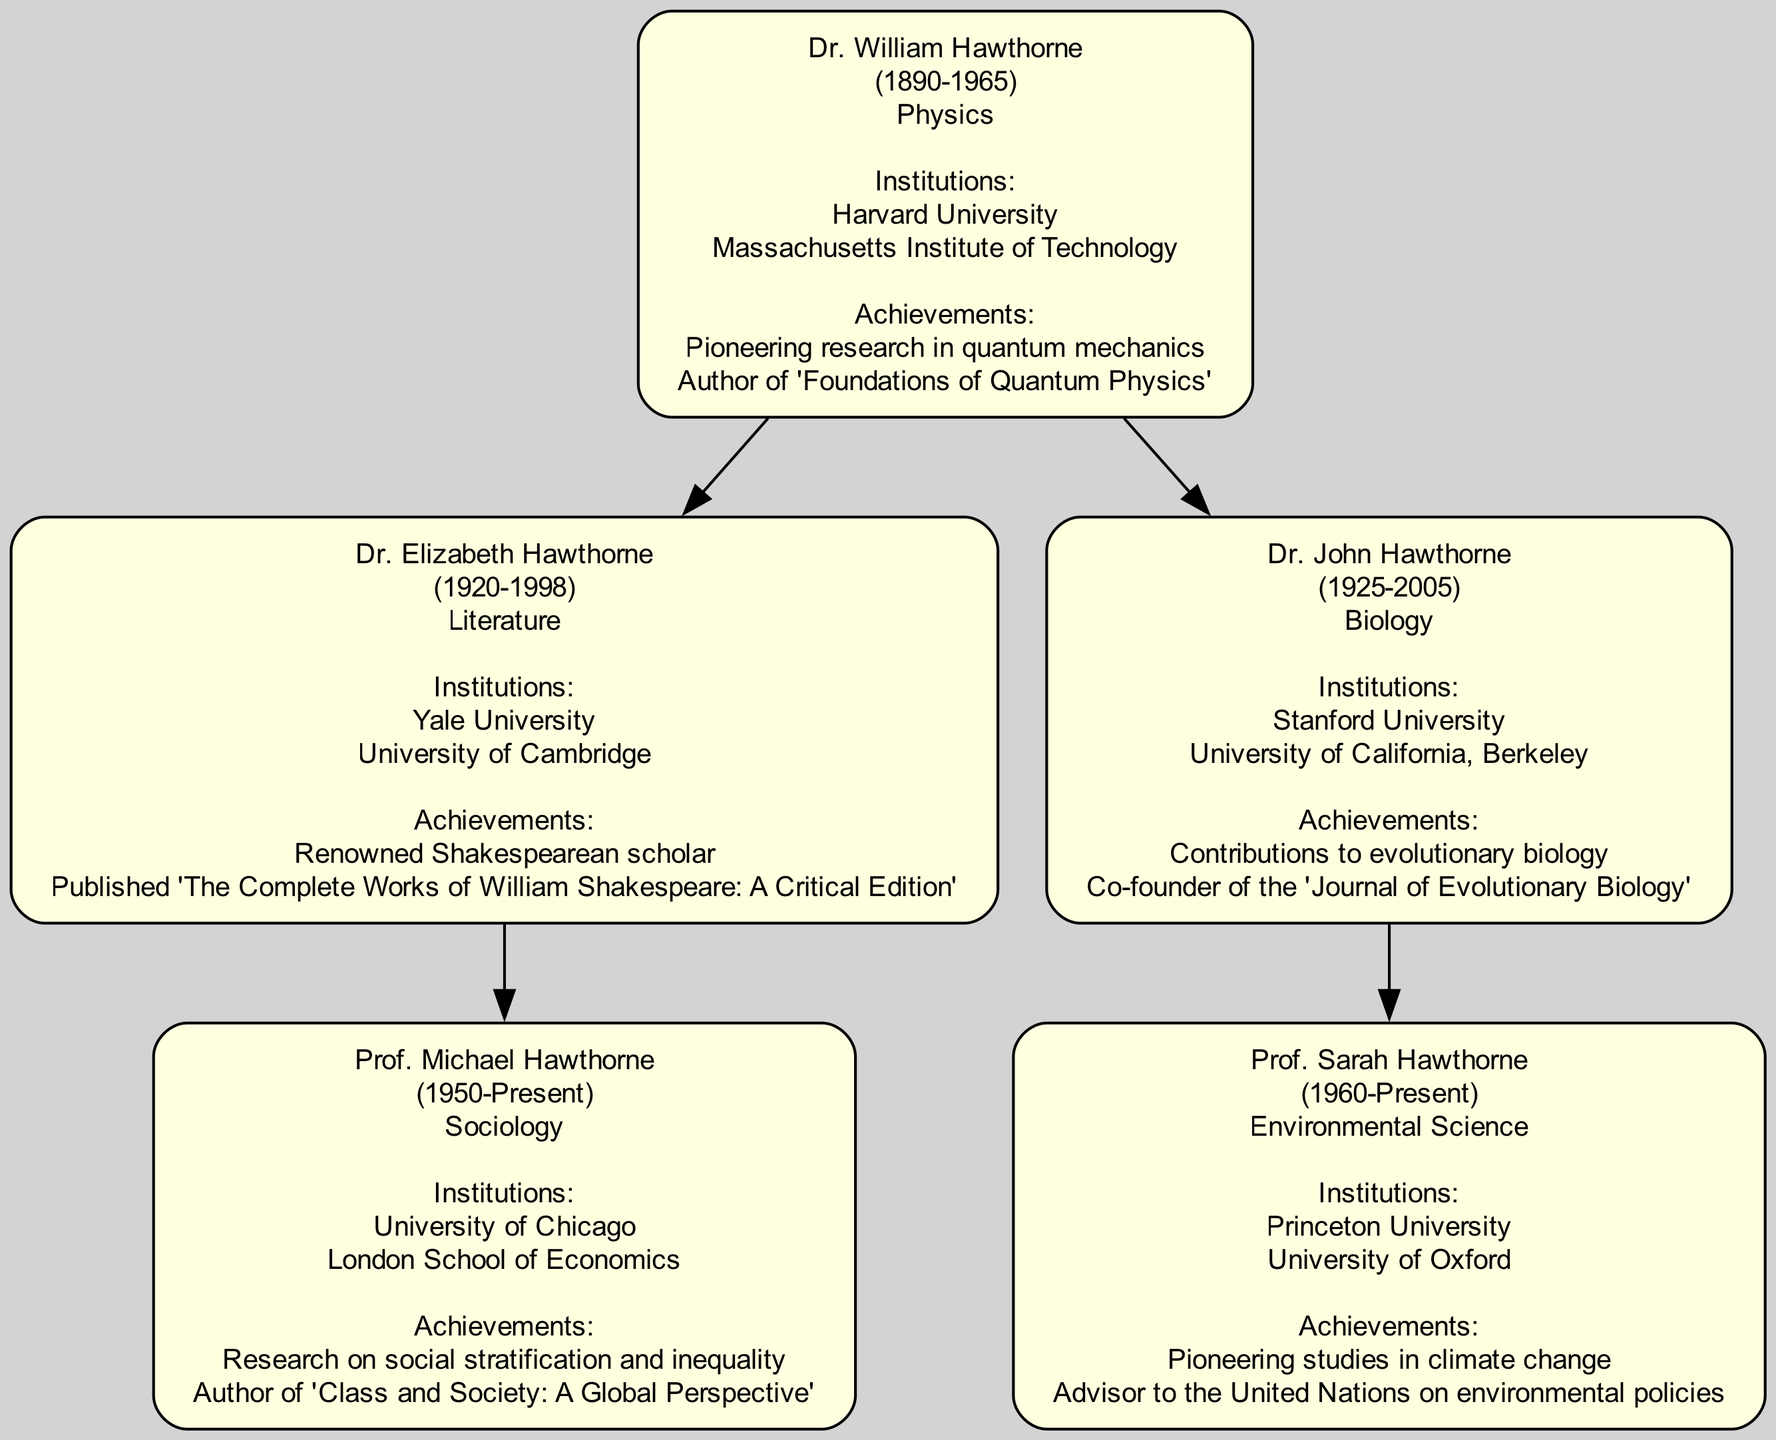What is the academic field of Dr. William Hawthorne? The diagram shows that Dr. William Hawthorne's academic field is Physics, as specified in the information provided under his name.
Answer: Physics How many children did Dr. Elizabeth Hawthorne have? Looking at the diagram, Dr. Elizabeth Hawthorne has one child listed, which is Prof. Michael Hawthorne.
Answer: 1 Who is the most recent scholar in the family tree? The diagram indicates that Prof. Sarah Hawthorne is the most recent scholar as she was born in 1960 and has no recorded death year, suggesting she is currently alive.
Answer: Prof. Sarah Hawthorne What were the notable achievements of Dr. John Hawthorne? The diagram outlines Dr. John Hawthorne's notable achievements as contributions to evolutionary biology and being a co-founder of the 'Journal of Evolutionary Biology'.
Answer: Contributions to evolutionary biology, co-founder of 'Journal of Evolutionary Biology' Which institution is associated with Prof. Michael Hawthorne? The diagram lists University of Chicago and London School of Economics as the institutions associated with Prof. Michael Hawthorne, located under his name in the diagram.
Answer: University of Chicago, London School of Economics How many scholars from the Hawthorne family are affiliated with Harvard University? The diagram shows that only Dr. William Hawthorne is affiliated with Harvard University, making it one scholar tied to that institution.
Answer: 1 Which family member is recognized as a renowned Shakespearean scholar? According to the information in the diagram, Dr. Elizabeth Hawthorne is recognized as a renowned Shakespearean scholar, as stated under her notable achievements.
Answer: Dr. Elizabeth Hawthorne What is the birth year of Prof. Michael Hawthorne? The diagram indicates that Prof. Michael Hawthorne was born in 1950, which is explicitly mentioned next to his name in the diagram.
Answer: 1950 Which academic institution is common between Dr. John Hawthorne and Prof. Sarah Hawthorne? Reviewing the affiliations listed in the diagram, Stanford University is common, as Dr. John Hawthorne is affiliated with it and Prof. Sarah Hawthorne’s childhood lineage traces back to him.
Answer: Stanford University 